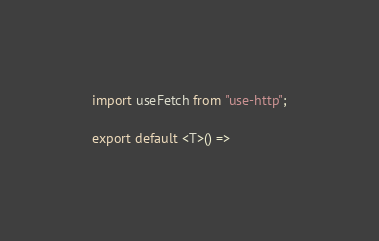<code> <loc_0><loc_0><loc_500><loc_500><_TypeScript_>import useFetch from "use-http";

export default <T>() =></code> 